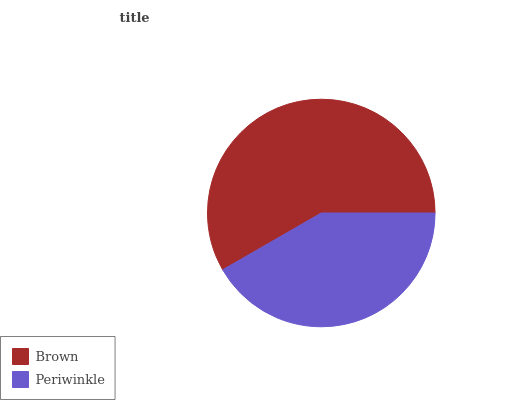Is Periwinkle the minimum?
Answer yes or no. Yes. Is Brown the maximum?
Answer yes or no. Yes. Is Periwinkle the maximum?
Answer yes or no. No. Is Brown greater than Periwinkle?
Answer yes or no. Yes. Is Periwinkle less than Brown?
Answer yes or no. Yes. Is Periwinkle greater than Brown?
Answer yes or no. No. Is Brown less than Periwinkle?
Answer yes or no. No. Is Brown the high median?
Answer yes or no. Yes. Is Periwinkle the low median?
Answer yes or no. Yes. Is Periwinkle the high median?
Answer yes or no. No. Is Brown the low median?
Answer yes or no. No. 